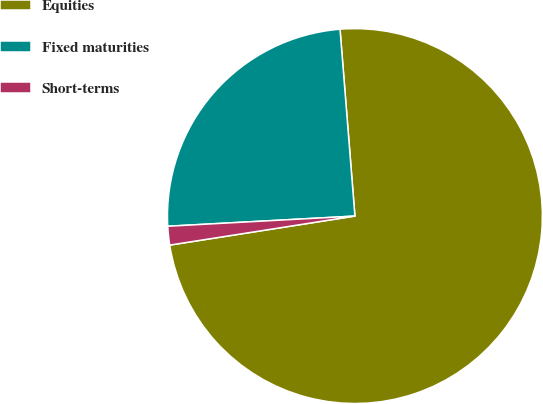Convert chart. <chart><loc_0><loc_0><loc_500><loc_500><pie_chart><fcel>Equities<fcel>Fixed maturities<fcel>Short-terms<nl><fcel>73.79%<fcel>24.6%<fcel>1.61%<nl></chart> 